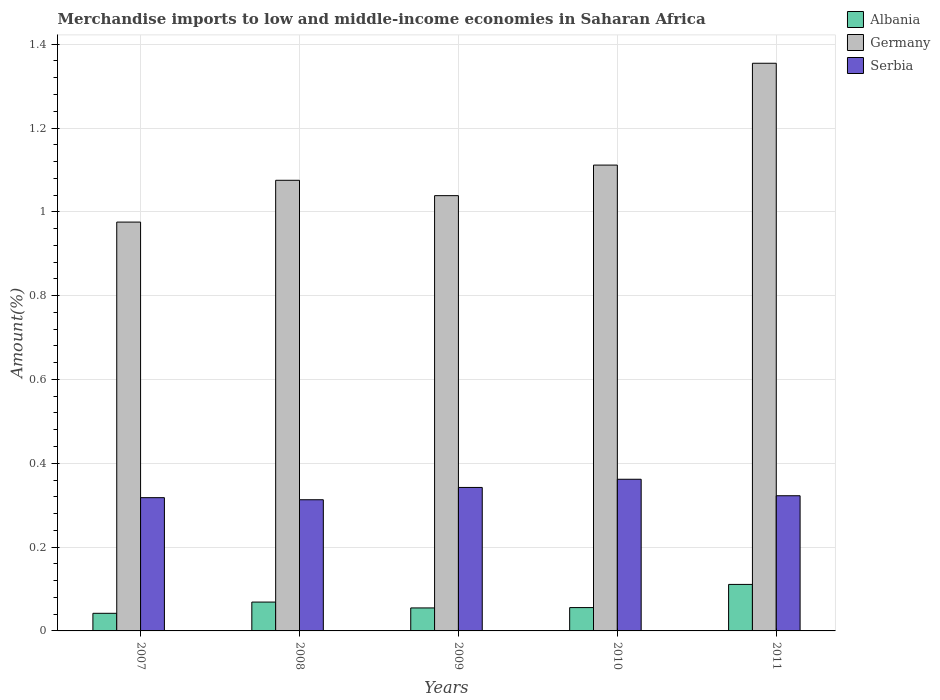How many different coloured bars are there?
Offer a terse response. 3. How many bars are there on the 1st tick from the right?
Your response must be concise. 3. What is the label of the 5th group of bars from the left?
Offer a terse response. 2011. What is the percentage of amount earned from merchandise imports in Albania in 2011?
Your answer should be compact. 0.11. Across all years, what is the maximum percentage of amount earned from merchandise imports in Albania?
Your answer should be compact. 0.11. Across all years, what is the minimum percentage of amount earned from merchandise imports in Albania?
Your answer should be very brief. 0.04. In which year was the percentage of amount earned from merchandise imports in Germany minimum?
Provide a succinct answer. 2007. What is the total percentage of amount earned from merchandise imports in Albania in the graph?
Offer a very short reply. 0.33. What is the difference between the percentage of amount earned from merchandise imports in Albania in 2008 and that in 2010?
Your response must be concise. 0.01. What is the difference between the percentage of amount earned from merchandise imports in Albania in 2008 and the percentage of amount earned from merchandise imports in Serbia in 2009?
Your answer should be compact. -0.27. What is the average percentage of amount earned from merchandise imports in Albania per year?
Your response must be concise. 0.07. In the year 2009, what is the difference between the percentage of amount earned from merchandise imports in Germany and percentage of amount earned from merchandise imports in Albania?
Your answer should be very brief. 0.98. What is the ratio of the percentage of amount earned from merchandise imports in Albania in 2009 to that in 2010?
Your answer should be very brief. 0.99. Is the difference between the percentage of amount earned from merchandise imports in Germany in 2007 and 2011 greater than the difference between the percentage of amount earned from merchandise imports in Albania in 2007 and 2011?
Keep it short and to the point. No. What is the difference between the highest and the second highest percentage of amount earned from merchandise imports in Albania?
Provide a short and direct response. 0.04. What is the difference between the highest and the lowest percentage of amount earned from merchandise imports in Albania?
Provide a short and direct response. 0.07. What does the 1st bar from the left in 2011 represents?
Make the answer very short. Albania. What does the 1st bar from the right in 2009 represents?
Make the answer very short. Serbia. Is it the case that in every year, the sum of the percentage of amount earned from merchandise imports in Albania and percentage of amount earned from merchandise imports in Serbia is greater than the percentage of amount earned from merchandise imports in Germany?
Your answer should be very brief. No. How many bars are there?
Offer a terse response. 15. Are all the bars in the graph horizontal?
Give a very brief answer. No. How many years are there in the graph?
Offer a terse response. 5. What is the difference between two consecutive major ticks on the Y-axis?
Offer a terse response. 0.2. Does the graph contain grids?
Give a very brief answer. Yes. How are the legend labels stacked?
Offer a terse response. Vertical. What is the title of the graph?
Make the answer very short. Merchandise imports to low and middle-income economies in Saharan Africa. What is the label or title of the Y-axis?
Provide a short and direct response. Amount(%). What is the Amount(%) in Albania in 2007?
Offer a very short reply. 0.04. What is the Amount(%) in Germany in 2007?
Ensure brevity in your answer.  0.98. What is the Amount(%) in Serbia in 2007?
Keep it short and to the point. 0.32. What is the Amount(%) in Albania in 2008?
Your response must be concise. 0.07. What is the Amount(%) of Germany in 2008?
Make the answer very short. 1.08. What is the Amount(%) in Serbia in 2008?
Your response must be concise. 0.31. What is the Amount(%) of Albania in 2009?
Provide a short and direct response. 0.05. What is the Amount(%) in Germany in 2009?
Offer a very short reply. 1.04. What is the Amount(%) of Serbia in 2009?
Keep it short and to the point. 0.34. What is the Amount(%) in Albania in 2010?
Your response must be concise. 0.06. What is the Amount(%) in Germany in 2010?
Keep it short and to the point. 1.11. What is the Amount(%) in Serbia in 2010?
Make the answer very short. 0.36. What is the Amount(%) of Albania in 2011?
Provide a short and direct response. 0.11. What is the Amount(%) in Germany in 2011?
Give a very brief answer. 1.35. What is the Amount(%) in Serbia in 2011?
Offer a terse response. 0.32. Across all years, what is the maximum Amount(%) of Albania?
Give a very brief answer. 0.11. Across all years, what is the maximum Amount(%) in Germany?
Provide a succinct answer. 1.35. Across all years, what is the maximum Amount(%) in Serbia?
Make the answer very short. 0.36. Across all years, what is the minimum Amount(%) of Albania?
Make the answer very short. 0.04. Across all years, what is the minimum Amount(%) of Germany?
Your response must be concise. 0.98. Across all years, what is the minimum Amount(%) of Serbia?
Your answer should be compact. 0.31. What is the total Amount(%) of Albania in the graph?
Make the answer very short. 0.33. What is the total Amount(%) in Germany in the graph?
Provide a short and direct response. 5.56. What is the total Amount(%) of Serbia in the graph?
Give a very brief answer. 1.66. What is the difference between the Amount(%) in Albania in 2007 and that in 2008?
Make the answer very short. -0.03. What is the difference between the Amount(%) in Germany in 2007 and that in 2008?
Your response must be concise. -0.1. What is the difference between the Amount(%) in Serbia in 2007 and that in 2008?
Give a very brief answer. 0.01. What is the difference between the Amount(%) in Albania in 2007 and that in 2009?
Provide a succinct answer. -0.01. What is the difference between the Amount(%) in Germany in 2007 and that in 2009?
Keep it short and to the point. -0.06. What is the difference between the Amount(%) of Serbia in 2007 and that in 2009?
Offer a very short reply. -0.02. What is the difference between the Amount(%) in Albania in 2007 and that in 2010?
Provide a succinct answer. -0.01. What is the difference between the Amount(%) in Germany in 2007 and that in 2010?
Your answer should be very brief. -0.14. What is the difference between the Amount(%) of Serbia in 2007 and that in 2010?
Your response must be concise. -0.04. What is the difference between the Amount(%) in Albania in 2007 and that in 2011?
Give a very brief answer. -0.07. What is the difference between the Amount(%) in Germany in 2007 and that in 2011?
Your response must be concise. -0.38. What is the difference between the Amount(%) of Serbia in 2007 and that in 2011?
Provide a short and direct response. -0. What is the difference between the Amount(%) in Albania in 2008 and that in 2009?
Make the answer very short. 0.01. What is the difference between the Amount(%) in Germany in 2008 and that in 2009?
Keep it short and to the point. 0.04. What is the difference between the Amount(%) in Serbia in 2008 and that in 2009?
Give a very brief answer. -0.03. What is the difference between the Amount(%) of Albania in 2008 and that in 2010?
Provide a succinct answer. 0.01. What is the difference between the Amount(%) in Germany in 2008 and that in 2010?
Your answer should be compact. -0.04. What is the difference between the Amount(%) of Serbia in 2008 and that in 2010?
Make the answer very short. -0.05. What is the difference between the Amount(%) in Albania in 2008 and that in 2011?
Offer a very short reply. -0.04. What is the difference between the Amount(%) of Germany in 2008 and that in 2011?
Your response must be concise. -0.28. What is the difference between the Amount(%) of Serbia in 2008 and that in 2011?
Keep it short and to the point. -0.01. What is the difference between the Amount(%) in Albania in 2009 and that in 2010?
Your answer should be very brief. -0. What is the difference between the Amount(%) in Germany in 2009 and that in 2010?
Your answer should be very brief. -0.07. What is the difference between the Amount(%) in Serbia in 2009 and that in 2010?
Your response must be concise. -0.02. What is the difference between the Amount(%) of Albania in 2009 and that in 2011?
Give a very brief answer. -0.06. What is the difference between the Amount(%) of Germany in 2009 and that in 2011?
Offer a very short reply. -0.32. What is the difference between the Amount(%) in Serbia in 2009 and that in 2011?
Give a very brief answer. 0.02. What is the difference between the Amount(%) of Albania in 2010 and that in 2011?
Your response must be concise. -0.06. What is the difference between the Amount(%) in Germany in 2010 and that in 2011?
Make the answer very short. -0.24. What is the difference between the Amount(%) of Serbia in 2010 and that in 2011?
Offer a very short reply. 0.04. What is the difference between the Amount(%) of Albania in 2007 and the Amount(%) of Germany in 2008?
Provide a succinct answer. -1.03. What is the difference between the Amount(%) in Albania in 2007 and the Amount(%) in Serbia in 2008?
Keep it short and to the point. -0.27. What is the difference between the Amount(%) of Germany in 2007 and the Amount(%) of Serbia in 2008?
Your response must be concise. 0.66. What is the difference between the Amount(%) of Albania in 2007 and the Amount(%) of Germany in 2009?
Ensure brevity in your answer.  -1. What is the difference between the Amount(%) in Albania in 2007 and the Amount(%) in Serbia in 2009?
Offer a very short reply. -0.3. What is the difference between the Amount(%) in Germany in 2007 and the Amount(%) in Serbia in 2009?
Give a very brief answer. 0.63. What is the difference between the Amount(%) in Albania in 2007 and the Amount(%) in Germany in 2010?
Offer a terse response. -1.07. What is the difference between the Amount(%) of Albania in 2007 and the Amount(%) of Serbia in 2010?
Keep it short and to the point. -0.32. What is the difference between the Amount(%) of Germany in 2007 and the Amount(%) of Serbia in 2010?
Give a very brief answer. 0.61. What is the difference between the Amount(%) of Albania in 2007 and the Amount(%) of Germany in 2011?
Give a very brief answer. -1.31. What is the difference between the Amount(%) of Albania in 2007 and the Amount(%) of Serbia in 2011?
Provide a succinct answer. -0.28. What is the difference between the Amount(%) of Germany in 2007 and the Amount(%) of Serbia in 2011?
Offer a very short reply. 0.65. What is the difference between the Amount(%) of Albania in 2008 and the Amount(%) of Germany in 2009?
Keep it short and to the point. -0.97. What is the difference between the Amount(%) in Albania in 2008 and the Amount(%) in Serbia in 2009?
Provide a short and direct response. -0.27. What is the difference between the Amount(%) of Germany in 2008 and the Amount(%) of Serbia in 2009?
Keep it short and to the point. 0.73. What is the difference between the Amount(%) in Albania in 2008 and the Amount(%) in Germany in 2010?
Offer a very short reply. -1.04. What is the difference between the Amount(%) in Albania in 2008 and the Amount(%) in Serbia in 2010?
Provide a succinct answer. -0.29. What is the difference between the Amount(%) in Germany in 2008 and the Amount(%) in Serbia in 2010?
Offer a terse response. 0.71. What is the difference between the Amount(%) in Albania in 2008 and the Amount(%) in Germany in 2011?
Ensure brevity in your answer.  -1.29. What is the difference between the Amount(%) of Albania in 2008 and the Amount(%) of Serbia in 2011?
Provide a short and direct response. -0.25. What is the difference between the Amount(%) of Germany in 2008 and the Amount(%) of Serbia in 2011?
Your response must be concise. 0.75. What is the difference between the Amount(%) of Albania in 2009 and the Amount(%) of Germany in 2010?
Make the answer very short. -1.06. What is the difference between the Amount(%) in Albania in 2009 and the Amount(%) in Serbia in 2010?
Offer a very short reply. -0.31. What is the difference between the Amount(%) in Germany in 2009 and the Amount(%) in Serbia in 2010?
Offer a terse response. 0.68. What is the difference between the Amount(%) in Albania in 2009 and the Amount(%) in Germany in 2011?
Make the answer very short. -1.3. What is the difference between the Amount(%) of Albania in 2009 and the Amount(%) of Serbia in 2011?
Give a very brief answer. -0.27. What is the difference between the Amount(%) of Germany in 2009 and the Amount(%) of Serbia in 2011?
Your answer should be very brief. 0.72. What is the difference between the Amount(%) in Albania in 2010 and the Amount(%) in Germany in 2011?
Give a very brief answer. -1.3. What is the difference between the Amount(%) in Albania in 2010 and the Amount(%) in Serbia in 2011?
Make the answer very short. -0.27. What is the difference between the Amount(%) of Germany in 2010 and the Amount(%) of Serbia in 2011?
Keep it short and to the point. 0.79. What is the average Amount(%) in Albania per year?
Keep it short and to the point. 0.07. What is the average Amount(%) of Serbia per year?
Your answer should be very brief. 0.33. In the year 2007, what is the difference between the Amount(%) in Albania and Amount(%) in Germany?
Your answer should be compact. -0.93. In the year 2007, what is the difference between the Amount(%) of Albania and Amount(%) of Serbia?
Give a very brief answer. -0.28. In the year 2007, what is the difference between the Amount(%) of Germany and Amount(%) of Serbia?
Offer a very short reply. 0.66. In the year 2008, what is the difference between the Amount(%) of Albania and Amount(%) of Germany?
Offer a very short reply. -1.01. In the year 2008, what is the difference between the Amount(%) in Albania and Amount(%) in Serbia?
Keep it short and to the point. -0.24. In the year 2008, what is the difference between the Amount(%) of Germany and Amount(%) of Serbia?
Provide a short and direct response. 0.76. In the year 2009, what is the difference between the Amount(%) of Albania and Amount(%) of Germany?
Ensure brevity in your answer.  -0.98. In the year 2009, what is the difference between the Amount(%) in Albania and Amount(%) in Serbia?
Your answer should be compact. -0.29. In the year 2009, what is the difference between the Amount(%) of Germany and Amount(%) of Serbia?
Ensure brevity in your answer.  0.7. In the year 2010, what is the difference between the Amount(%) of Albania and Amount(%) of Germany?
Offer a terse response. -1.06. In the year 2010, what is the difference between the Amount(%) in Albania and Amount(%) in Serbia?
Ensure brevity in your answer.  -0.31. In the year 2010, what is the difference between the Amount(%) in Germany and Amount(%) in Serbia?
Offer a very short reply. 0.75. In the year 2011, what is the difference between the Amount(%) of Albania and Amount(%) of Germany?
Your response must be concise. -1.24. In the year 2011, what is the difference between the Amount(%) of Albania and Amount(%) of Serbia?
Offer a very short reply. -0.21. In the year 2011, what is the difference between the Amount(%) in Germany and Amount(%) in Serbia?
Provide a short and direct response. 1.03. What is the ratio of the Amount(%) in Albania in 2007 to that in 2008?
Offer a terse response. 0.61. What is the ratio of the Amount(%) in Germany in 2007 to that in 2008?
Provide a succinct answer. 0.91. What is the ratio of the Amount(%) in Serbia in 2007 to that in 2008?
Your response must be concise. 1.02. What is the ratio of the Amount(%) of Albania in 2007 to that in 2009?
Provide a succinct answer. 0.77. What is the ratio of the Amount(%) of Germany in 2007 to that in 2009?
Provide a short and direct response. 0.94. What is the ratio of the Amount(%) in Serbia in 2007 to that in 2009?
Offer a very short reply. 0.93. What is the ratio of the Amount(%) of Albania in 2007 to that in 2010?
Provide a succinct answer. 0.76. What is the ratio of the Amount(%) of Germany in 2007 to that in 2010?
Offer a terse response. 0.88. What is the ratio of the Amount(%) of Serbia in 2007 to that in 2010?
Provide a short and direct response. 0.88. What is the ratio of the Amount(%) in Albania in 2007 to that in 2011?
Give a very brief answer. 0.38. What is the ratio of the Amount(%) in Germany in 2007 to that in 2011?
Your answer should be very brief. 0.72. What is the ratio of the Amount(%) in Serbia in 2007 to that in 2011?
Your answer should be very brief. 0.99. What is the ratio of the Amount(%) in Albania in 2008 to that in 2009?
Provide a succinct answer. 1.25. What is the ratio of the Amount(%) of Germany in 2008 to that in 2009?
Give a very brief answer. 1.04. What is the ratio of the Amount(%) in Serbia in 2008 to that in 2009?
Keep it short and to the point. 0.91. What is the ratio of the Amount(%) of Albania in 2008 to that in 2010?
Make the answer very short. 1.24. What is the ratio of the Amount(%) in Germany in 2008 to that in 2010?
Your answer should be very brief. 0.97. What is the ratio of the Amount(%) in Serbia in 2008 to that in 2010?
Make the answer very short. 0.86. What is the ratio of the Amount(%) of Albania in 2008 to that in 2011?
Your answer should be compact. 0.62. What is the ratio of the Amount(%) of Germany in 2008 to that in 2011?
Offer a very short reply. 0.79. What is the ratio of the Amount(%) in Serbia in 2008 to that in 2011?
Your answer should be very brief. 0.97. What is the ratio of the Amount(%) of Albania in 2009 to that in 2010?
Provide a succinct answer. 0.99. What is the ratio of the Amount(%) of Germany in 2009 to that in 2010?
Ensure brevity in your answer.  0.93. What is the ratio of the Amount(%) in Serbia in 2009 to that in 2010?
Give a very brief answer. 0.95. What is the ratio of the Amount(%) of Albania in 2009 to that in 2011?
Make the answer very short. 0.49. What is the ratio of the Amount(%) in Germany in 2009 to that in 2011?
Offer a terse response. 0.77. What is the ratio of the Amount(%) in Serbia in 2009 to that in 2011?
Your answer should be compact. 1.06. What is the ratio of the Amount(%) of Albania in 2010 to that in 2011?
Provide a short and direct response. 0.5. What is the ratio of the Amount(%) of Germany in 2010 to that in 2011?
Provide a short and direct response. 0.82. What is the ratio of the Amount(%) of Serbia in 2010 to that in 2011?
Offer a very short reply. 1.12. What is the difference between the highest and the second highest Amount(%) of Albania?
Offer a very short reply. 0.04. What is the difference between the highest and the second highest Amount(%) in Germany?
Your answer should be very brief. 0.24. What is the difference between the highest and the second highest Amount(%) of Serbia?
Offer a very short reply. 0.02. What is the difference between the highest and the lowest Amount(%) of Albania?
Make the answer very short. 0.07. What is the difference between the highest and the lowest Amount(%) in Germany?
Provide a succinct answer. 0.38. What is the difference between the highest and the lowest Amount(%) in Serbia?
Your answer should be very brief. 0.05. 